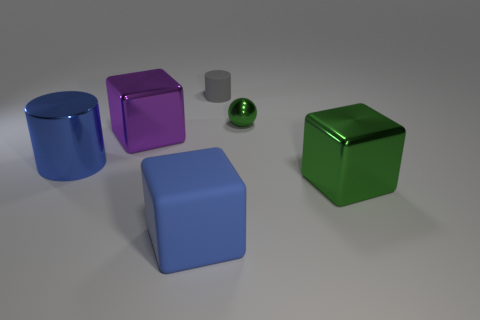What is the material of the big cylinder that is the same color as the matte block?
Your answer should be very brief. Metal. What shape is the big metallic object that is the same color as the small metal thing?
Your response must be concise. Cube. What is the size of the cube that is the same color as the tiny metal sphere?
Keep it short and to the point. Large. What number of things are either cubes to the left of the gray rubber cylinder or metal objects behind the green metal block?
Ensure brevity in your answer.  4. Are there any green metallic spheres behind the small gray rubber cylinder?
Your answer should be compact. No. The cylinder to the right of the blue object on the right side of the metal cube to the left of the tiny matte cylinder is what color?
Provide a succinct answer. Gray. Does the large blue rubber thing have the same shape as the tiny gray object?
Make the answer very short. No. There is another block that is made of the same material as the green block; what is its color?
Make the answer very short. Purple. How many objects are either cubes left of the green cube or big blue metal cylinders?
Offer a very short reply. 3. What size is the green metal object that is in front of the tiny metal object?
Offer a very short reply. Large. 